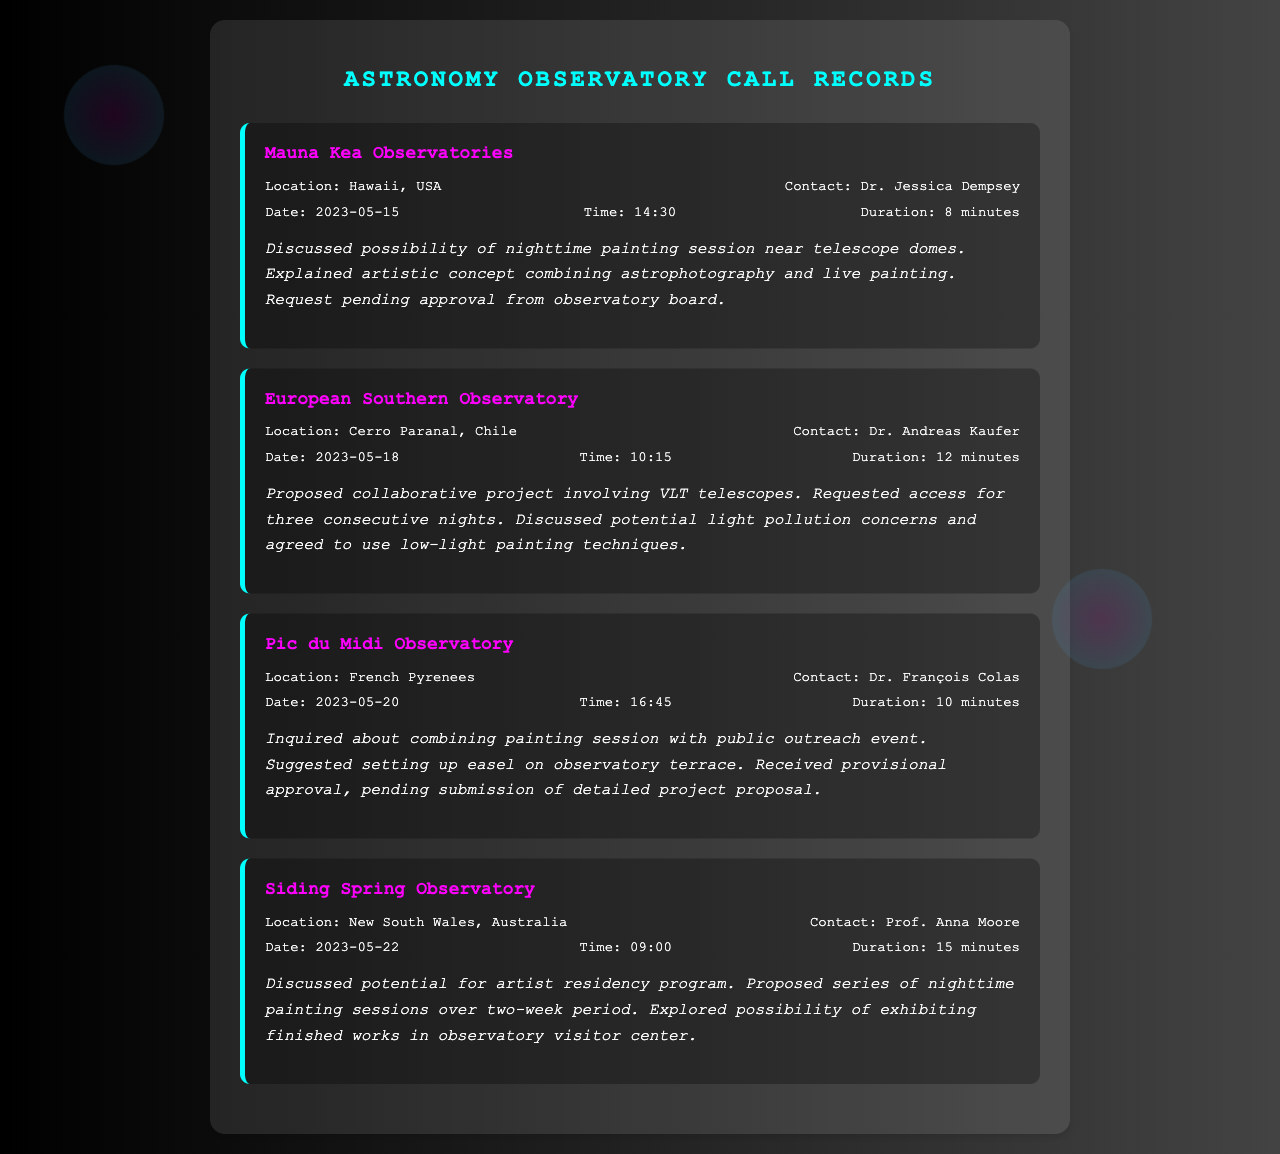What is the location of Mauna Kea Observatories? The document lists the location of Mauna Kea Observatories as Hawaii, USA.
Answer: Hawaii, USA Who is the contact person for the European Southern Observatory? The document states that the contact person for the European Southern Observatory is Dr. Andreas Kaufer.
Answer: Dr. Andreas Kaufer What date was the call to Pic du Midi Observatory made? According to the document, the call to Pic du Midi Observatory was made on May 20, 2023.
Answer: 2023-05-20 How long was the call to Siding Spring Observatory? The document specifies that the duration of the call to Siding Spring Observatory was 15 minutes.
Answer: 15 minutes What was the main topic discussed with Mauna Kea Observatories? The call primarily discussed the possibility of a nighttime painting session near telescope domes.
Answer: nighttime painting session What was agreed upon regarding light pollution with the European Southern Observatory? The document mentions that they agreed to use low-light painting techniques to mitigate light pollution concerns.
Answer: low-light painting techniques What did the call to Pic du Midi Observatory receive? The call received provisional approval pending a detailed project proposal submission.
Answer: provisional approval How many consecutive nights were requested at the European Southern Observatory? The document states that access for three consecutive nights was requested.
Answer: three consecutive nights What type of project was discussed for Siding Spring Observatory? The document notes the discussion of an artist residency program.
Answer: artist residency program 